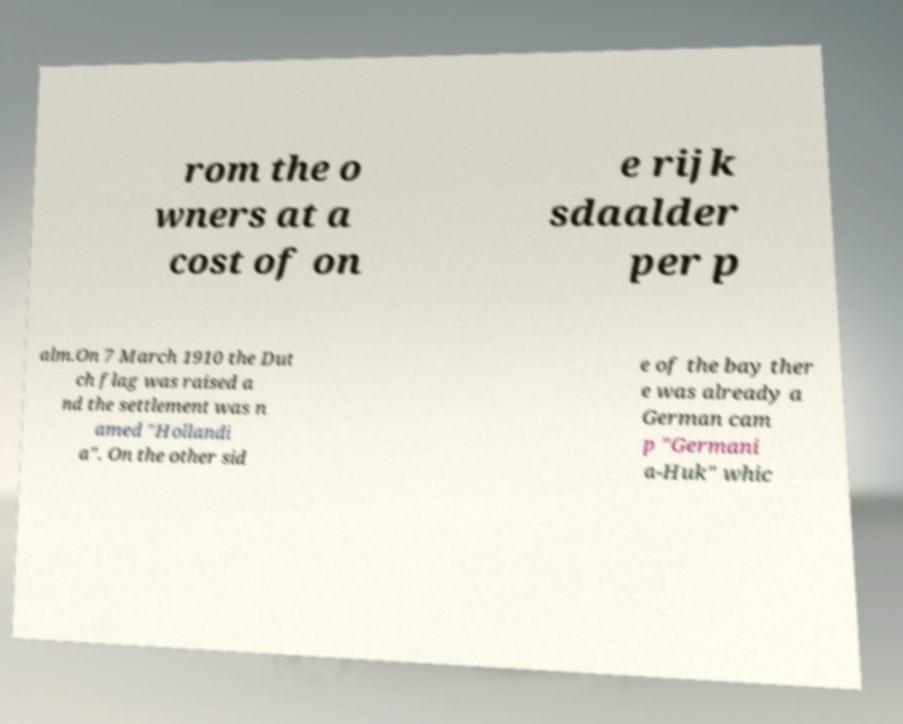Please identify and transcribe the text found in this image. rom the o wners at a cost of on e rijk sdaalder per p alm.On 7 March 1910 the Dut ch flag was raised a nd the settlement was n amed "Hollandi a". On the other sid e of the bay ther e was already a German cam p "Germani a-Huk" whic 